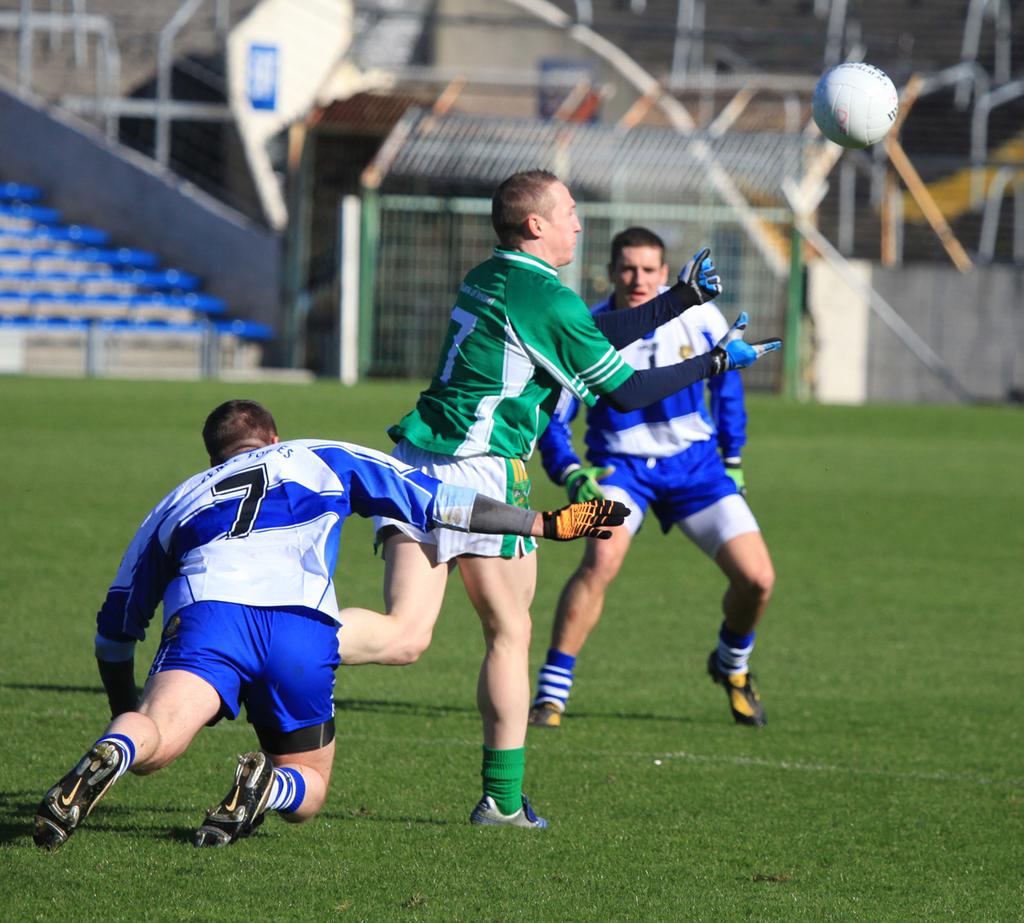What number is on the blue and white shirt?
Offer a very short reply. 7. What is the number on the jersey?
Offer a very short reply. 7. 